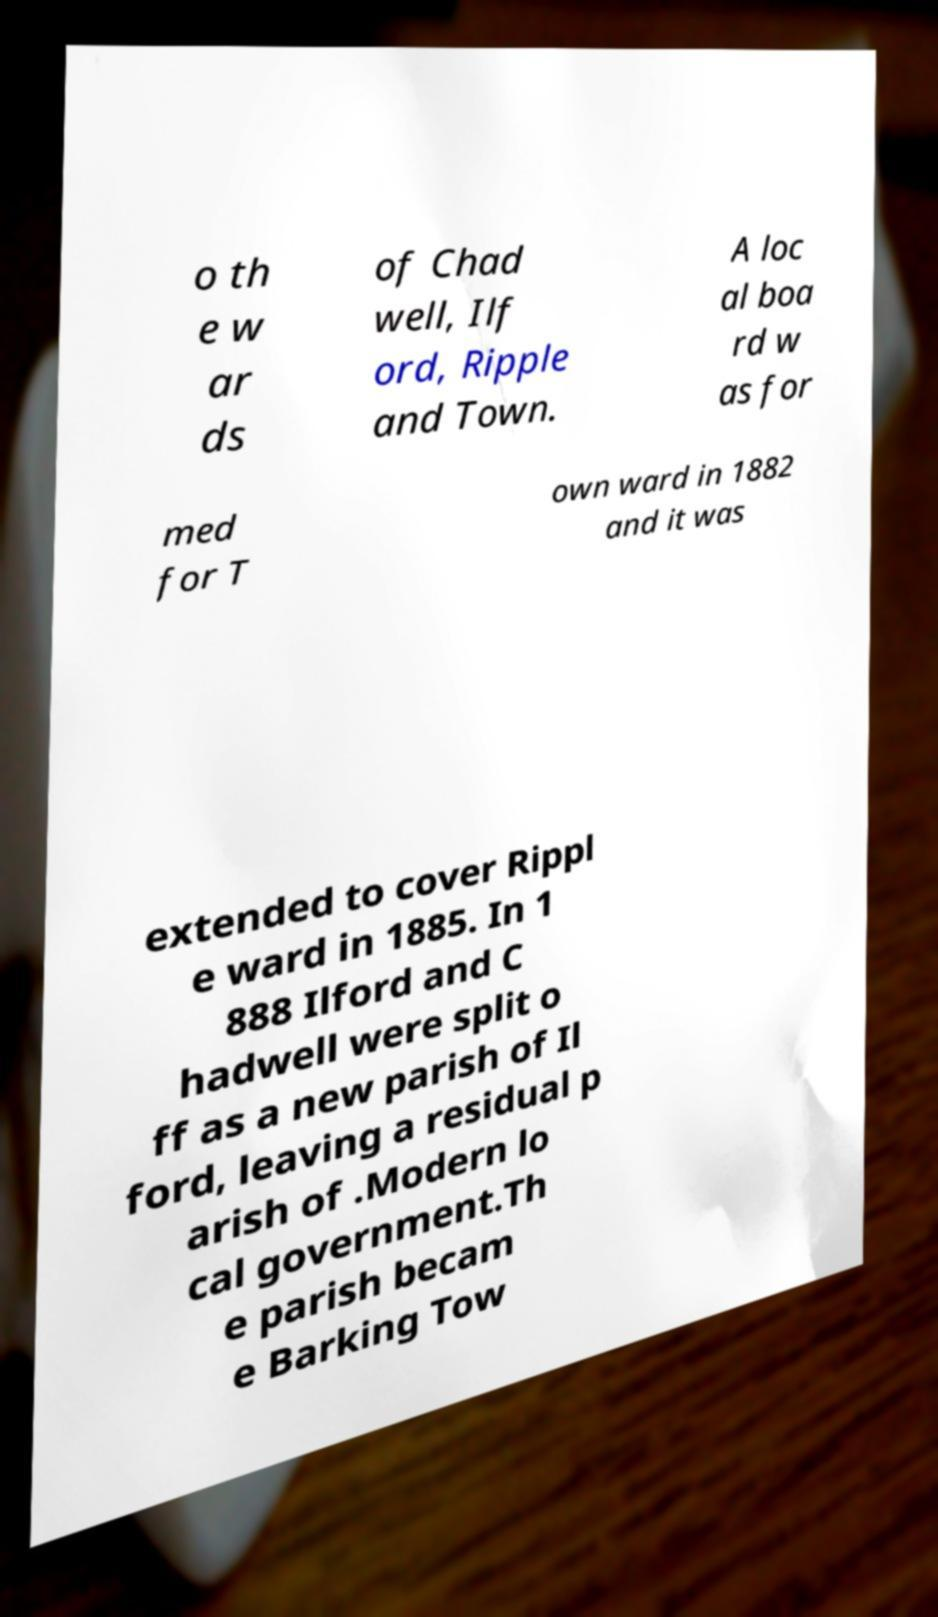Please read and relay the text visible in this image. What does it say? o th e w ar ds of Chad well, Ilf ord, Ripple and Town. A loc al boa rd w as for med for T own ward in 1882 and it was extended to cover Rippl e ward in 1885. In 1 888 Ilford and C hadwell were split o ff as a new parish of Il ford, leaving a residual p arish of .Modern lo cal government.Th e parish becam e Barking Tow 